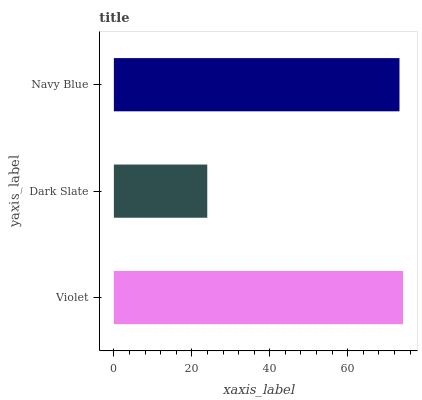Is Dark Slate the minimum?
Answer yes or no. Yes. Is Violet the maximum?
Answer yes or no. Yes. Is Navy Blue the minimum?
Answer yes or no. No. Is Navy Blue the maximum?
Answer yes or no. No. Is Navy Blue greater than Dark Slate?
Answer yes or no. Yes. Is Dark Slate less than Navy Blue?
Answer yes or no. Yes. Is Dark Slate greater than Navy Blue?
Answer yes or no. No. Is Navy Blue less than Dark Slate?
Answer yes or no. No. Is Navy Blue the high median?
Answer yes or no. Yes. Is Navy Blue the low median?
Answer yes or no. Yes. Is Dark Slate the high median?
Answer yes or no. No. Is Violet the low median?
Answer yes or no. No. 